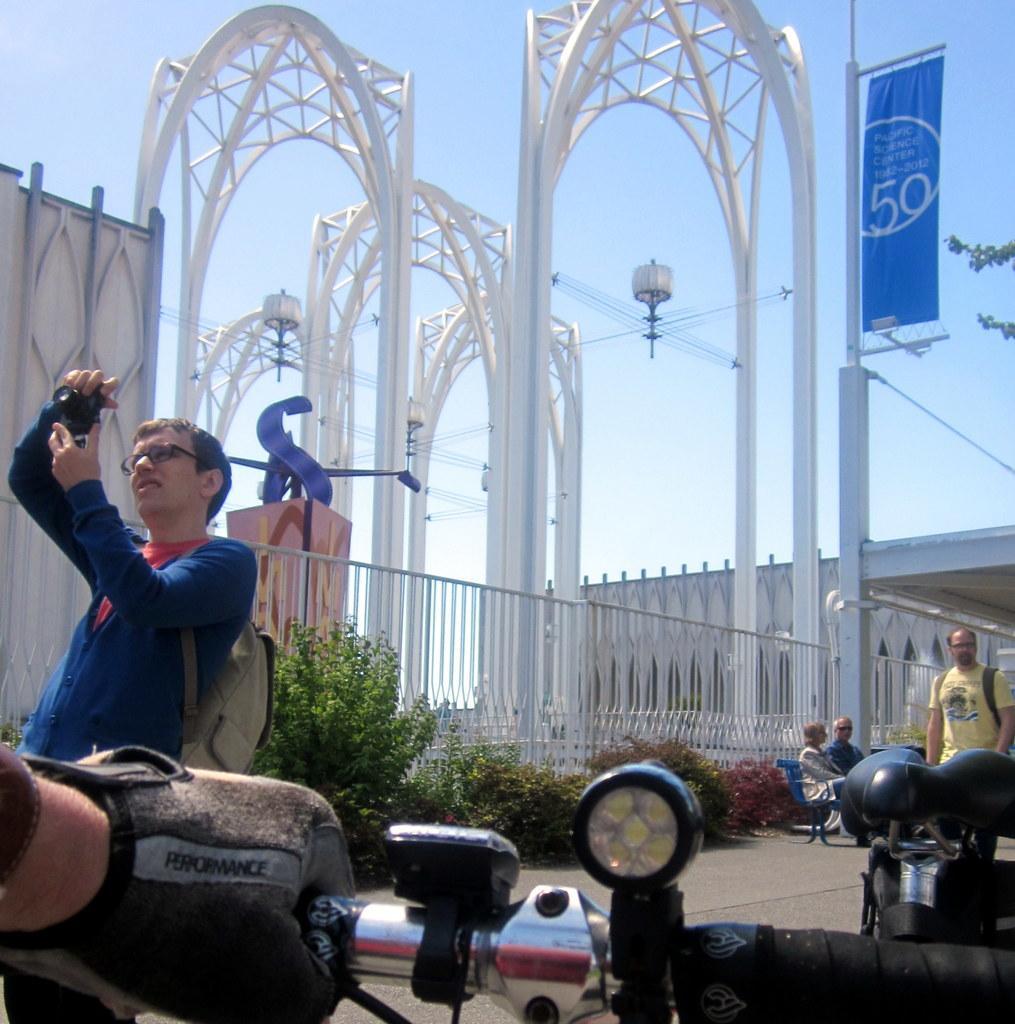Please provide a concise description of this image. In this image I can see people among them some are standing and some are sitting on a bench. In the background I can see fence, poles which has wires and a banner. On the banner I can see something written on it. Here I can see planets and this man is holding a camera in the hand. In the background I can see the sky. 